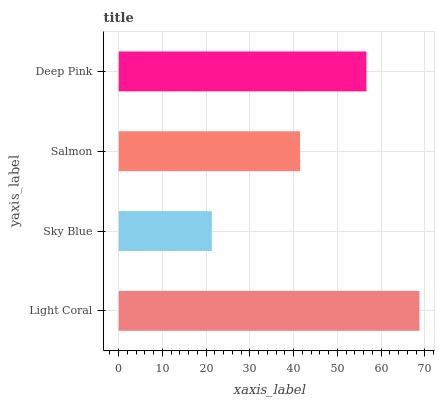Is Sky Blue the minimum?
Answer yes or no. Yes. Is Light Coral the maximum?
Answer yes or no. Yes. Is Salmon the minimum?
Answer yes or no. No. Is Salmon the maximum?
Answer yes or no. No. Is Salmon greater than Sky Blue?
Answer yes or no. Yes. Is Sky Blue less than Salmon?
Answer yes or no. Yes. Is Sky Blue greater than Salmon?
Answer yes or no. No. Is Salmon less than Sky Blue?
Answer yes or no. No. Is Deep Pink the high median?
Answer yes or no. Yes. Is Salmon the low median?
Answer yes or no. Yes. Is Sky Blue the high median?
Answer yes or no. No. Is Light Coral the low median?
Answer yes or no. No. 